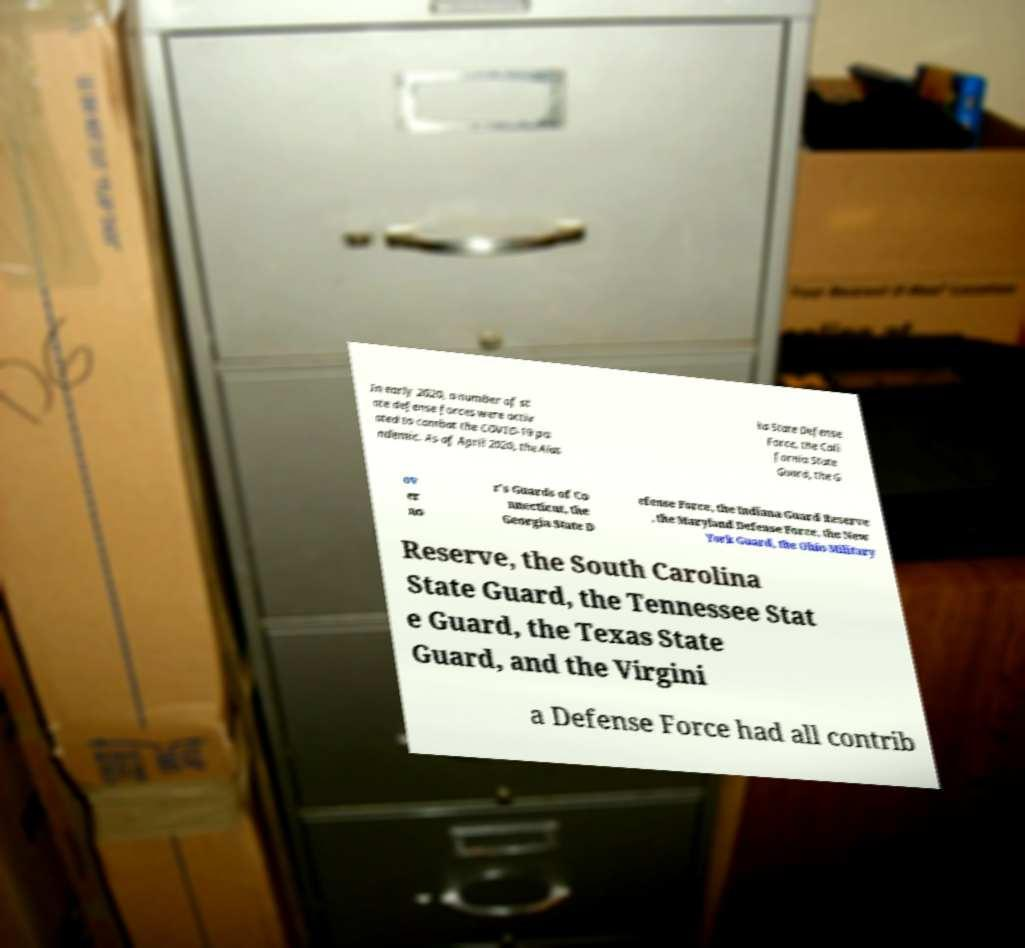There's text embedded in this image that I need extracted. Can you transcribe it verbatim? In early 2020, a number of st ate defense forces were activ ated to combat the COVID-19 pa ndemic. As of April 2020, the Alas ka State Defense Force, the Cali fornia State Guard, the G ov er no r's Guards of Co nnecticut, the Georgia State D efense Force, the Indiana Guard Reserve , the Maryland Defense Force, the New York Guard, the Ohio Military Reserve, the South Carolina State Guard, the Tennessee Stat e Guard, the Texas State Guard, and the Virgini a Defense Force had all contrib 